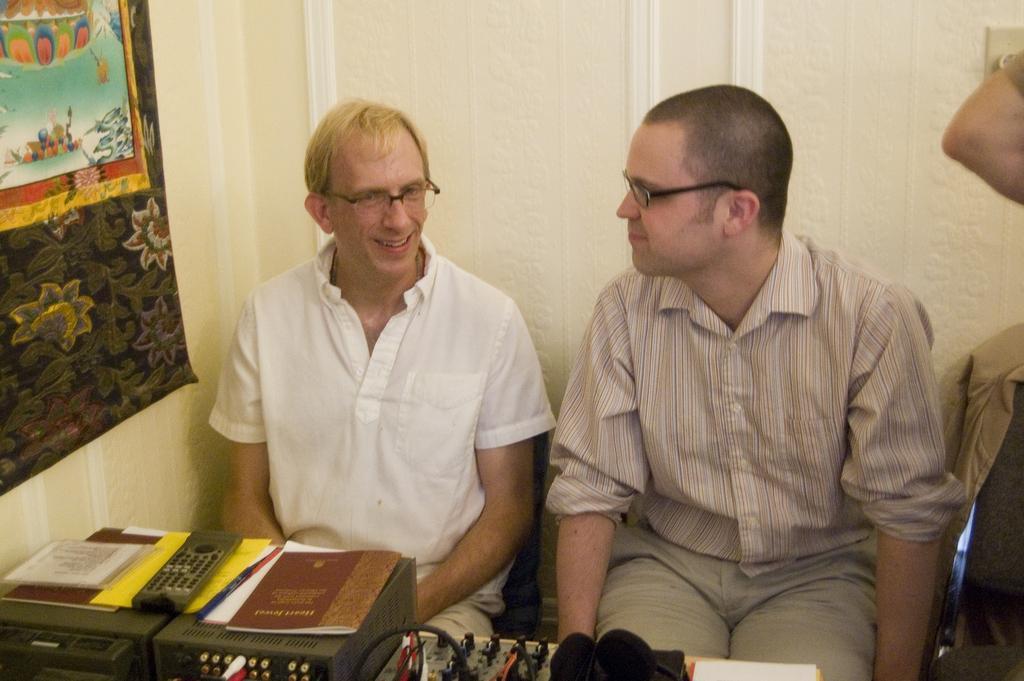How would you summarize this image in a sentence or two? In this image two persons are sitting. In front of them there are few electronic instruments, books, remote. In the right a person's hand is visible. Here there is a hanging. In the background there is wall. 